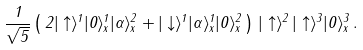<formula> <loc_0><loc_0><loc_500><loc_500>\frac { 1 } { \sqrt { 5 } } \left ( \, 2 | \uparrow \rangle ^ { 1 } | 0 \rangle _ { x } ^ { 1 } | \alpha \rangle _ { x } ^ { 2 } + | \downarrow \rangle ^ { 1 } | \alpha \rangle _ { x } ^ { 1 } | 0 \rangle _ { x } ^ { 2 } \, \right ) \, | \uparrow \rangle ^ { 2 } \, | \uparrow \rangle ^ { 3 } | 0 \rangle _ { x } ^ { 3 } \, .</formula> 